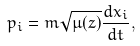<formula> <loc_0><loc_0><loc_500><loc_500>p _ { i } = m \sqrt { \mu ( z ) } \frac { d x _ { i } } { d t } ,</formula> 